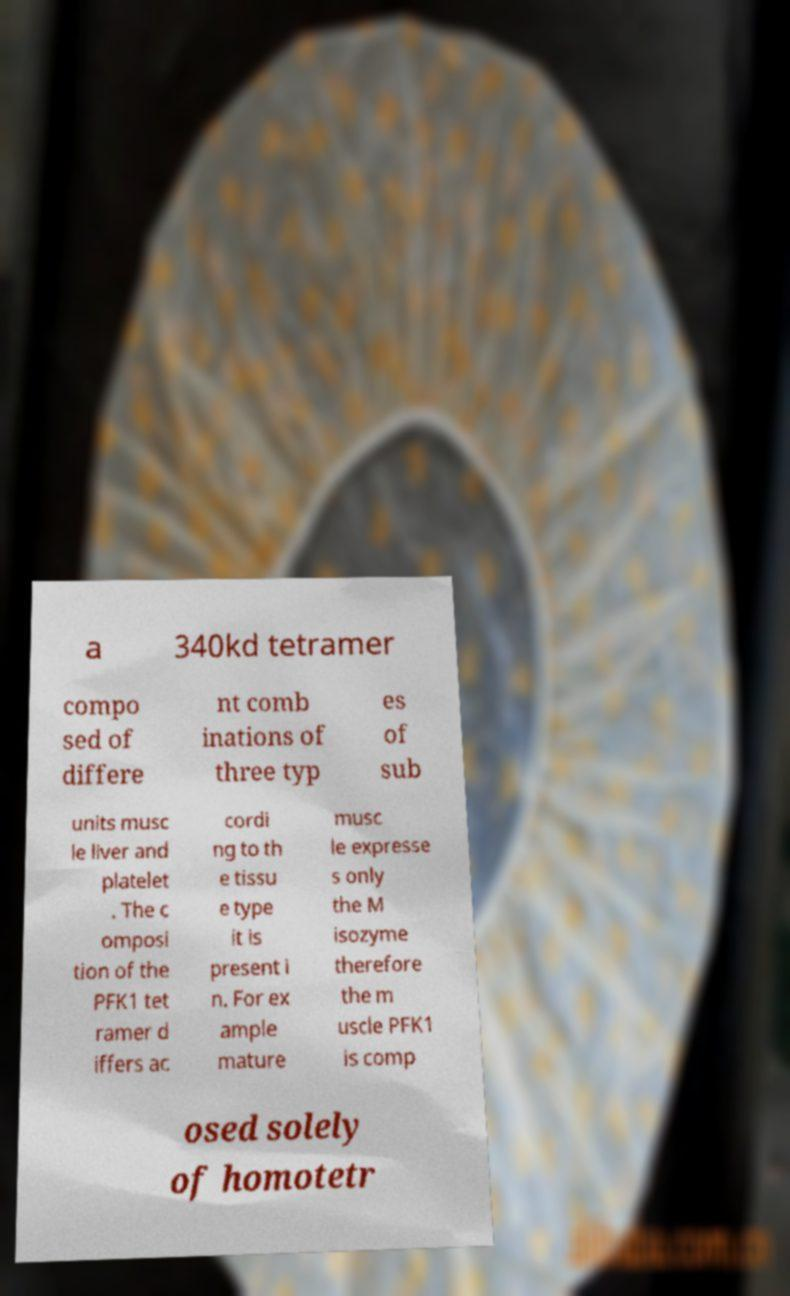What messages or text are displayed in this image? I need them in a readable, typed format. a 340kd tetramer compo sed of differe nt comb inations of three typ es of sub units musc le liver and platelet . The c omposi tion of the PFK1 tet ramer d iffers ac cordi ng to th e tissu e type it is present i n. For ex ample mature musc le expresse s only the M isozyme therefore the m uscle PFK1 is comp osed solely of homotetr 